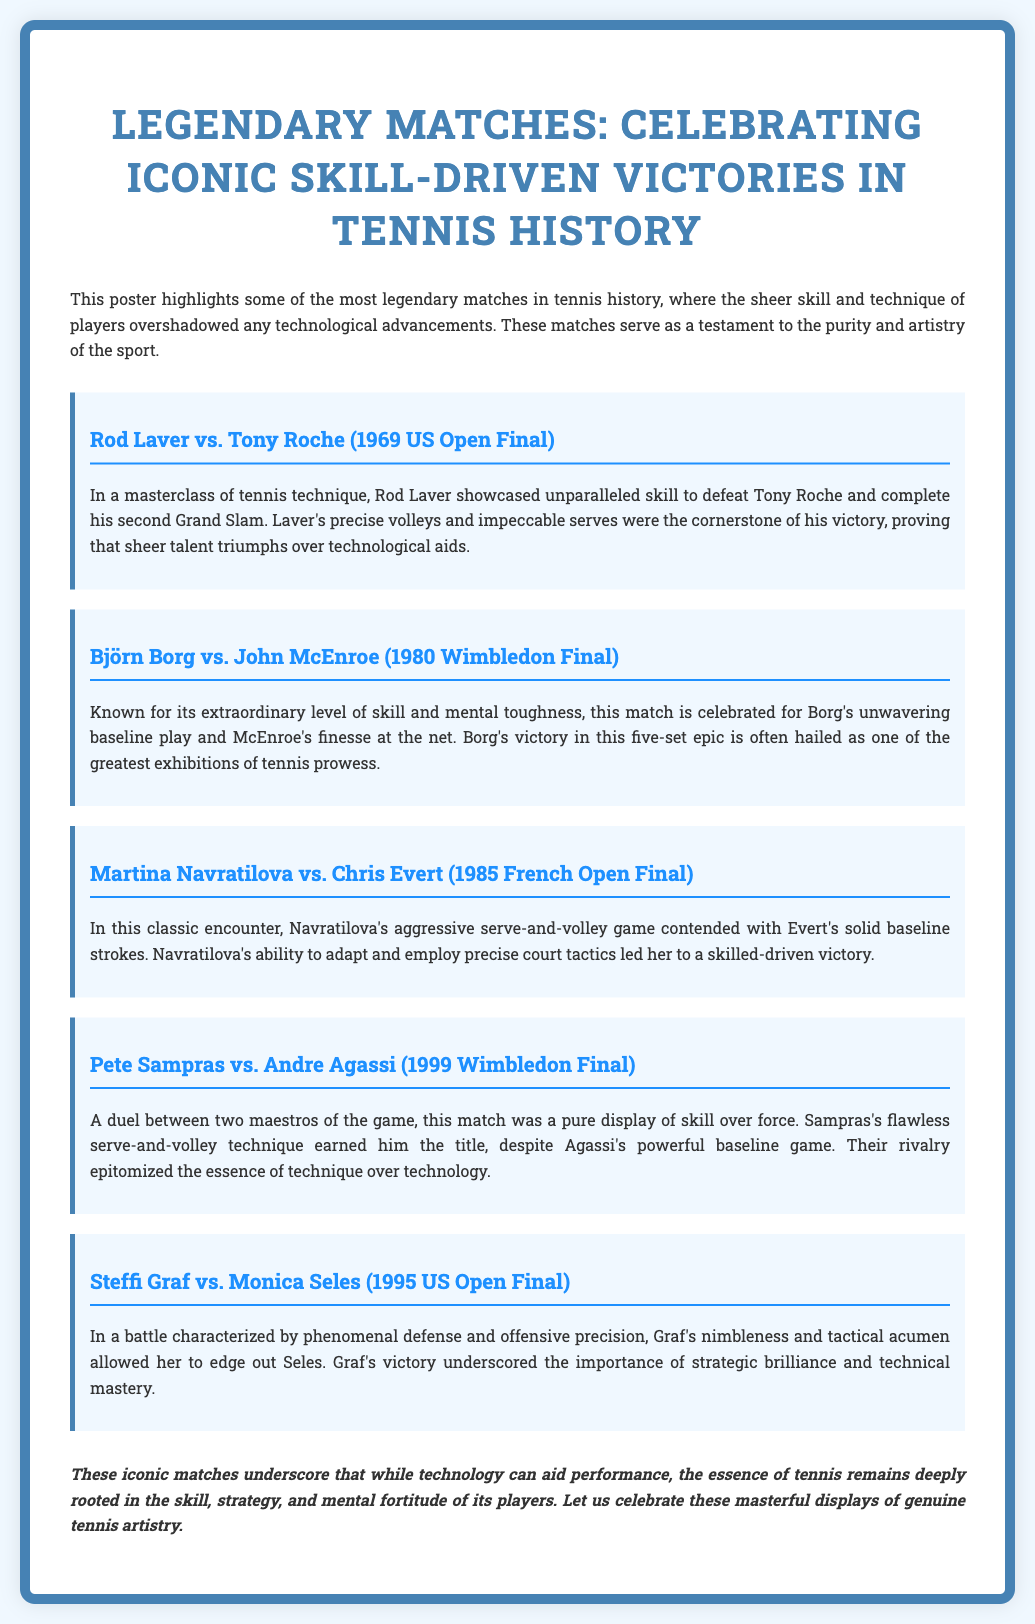What is the title of the poster? The title of the poster is provided prominently at the top, which encapsulates the main theme.
Answer: Legendary Matches: Celebrating Iconic Skill-Driven Victories in Tennis History Who defeated Tony Roche in the 1969 US Open Final? The document clearly states that Rod Laver defeated Tony Roche in this match.
Answer: Rod Laver In which year did the match between Borg and McEnroe occur? The document provides the year of this iconic match, which is crucial for historical context.
Answer: 1980 What style of play characterized Navratilova's game in the 1985 French Open Final? The document mentions Navratilova's aggressive serve-and-volley game as key to her approach in this match.
Answer: Serve-and-volley Which player is noted for their tactical acumen in the 1995 US Open Final? The document highlights Graf's nimbleness and tactical acumen in relation to this match against Seles.
Answer: Graf How many sets were played in the Borg vs. McEnroe match? The document describes the match as a five-set epic, indicating the number of sets played.
Answer: Five Which two players are referred to as maestros of the game? The document specifies that Sampras and Agassi are referred to as maestros, showcasing their skill levels.
Answer: Sampras and Agassi What is emphasized as remaining at the essence of tennis despite technological advancements? The document implies that skill, strategy, and mental fortitude are central to the sport, regardless of technological influence.
Answer: Skill, strategy, and mental fortitude 